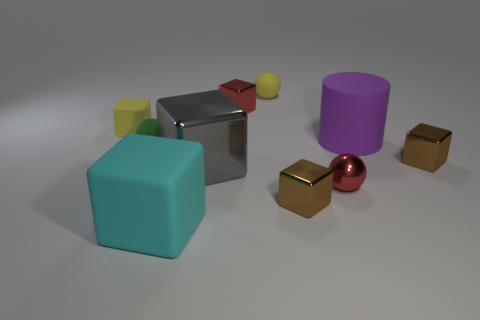Are there any tiny yellow rubber cubes in front of the cyan object?
Offer a very short reply. No. There is a matte cube that is in front of the small brown shiny block behind the large shiny object; how big is it?
Offer a terse response. Large. Are there an equal number of tiny red spheres in front of the cyan block and large cyan matte blocks that are in front of the red metallic block?
Provide a succinct answer. No. Is there a metal object behind the yellow rubber thing that is to the left of the green object?
Keep it short and to the point. Yes. There is a shiny object that is in front of the red shiny thing in front of the cylinder; how many small brown objects are on the right side of it?
Your answer should be compact. 1. Is the number of gray metal blocks less than the number of yellow things?
Provide a short and direct response. Yes. Is the shape of the tiny yellow object that is left of the big rubber block the same as the tiny red object that is behind the purple cylinder?
Provide a succinct answer. Yes. The metallic sphere has what color?
Offer a very short reply. Red. What number of rubber things are either tiny green things or red balls?
Give a very brief answer. 1. The large shiny object that is the same shape as the big cyan matte thing is what color?
Make the answer very short. Gray. 